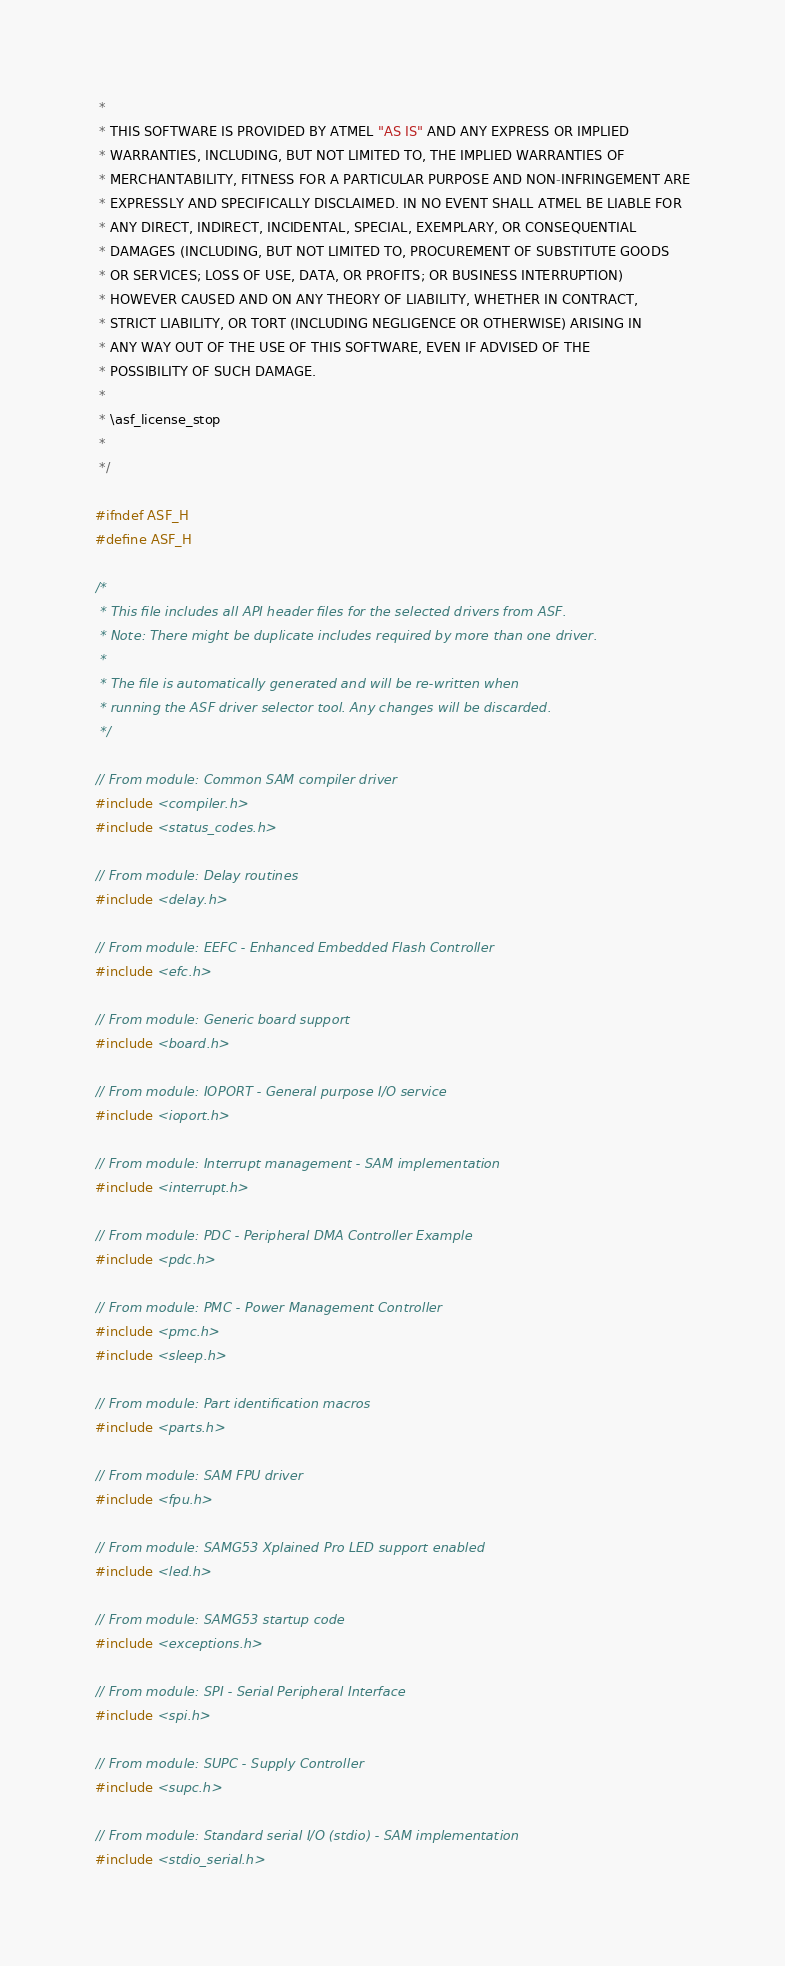Convert code to text. <code><loc_0><loc_0><loc_500><loc_500><_C_> *
 * THIS SOFTWARE IS PROVIDED BY ATMEL "AS IS" AND ANY EXPRESS OR IMPLIED
 * WARRANTIES, INCLUDING, BUT NOT LIMITED TO, THE IMPLIED WARRANTIES OF
 * MERCHANTABILITY, FITNESS FOR A PARTICULAR PURPOSE AND NON-INFRINGEMENT ARE
 * EXPRESSLY AND SPECIFICALLY DISCLAIMED. IN NO EVENT SHALL ATMEL BE LIABLE FOR
 * ANY DIRECT, INDIRECT, INCIDENTAL, SPECIAL, EXEMPLARY, OR CONSEQUENTIAL
 * DAMAGES (INCLUDING, BUT NOT LIMITED TO, PROCUREMENT OF SUBSTITUTE GOODS
 * OR SERVICES; LOSS OF USE, DATA, OR PROFITS; OR BUSINESS INTERRUPTION)
 * HOWEVER CAUSED AND ON ANY THEORY OF LIABILITY, WHETHER IN CONTRACT,
 * STRICT LIABILITY, OR TORT (INCLUDING NEGLIGENCE OR OTHERWISE) ARISING IN
 * ANY WAY OUT OF THE USE OF THIS SOFTWARE, EVEN IF ADVISED OF THE
 * POSSIBILITY OF SUCH DAMAGE.
 *
 * \asf_license_stop
 *
 */

#ifndef ASF_H
#define ASF_H

/*
 * This file includes all API header files for the selected drivers from ASF.
 * Note: There might be duplicate includes required by more than one driver.
 *
 * The file is automatically generated and will be re-written when
 * running the ASF driver selector tool. Any changes will be discarded.
 */

// From module: Common SAM compiler driver
#include <compiler.h>
#include <status_codes.h>

// From module: Delay routines
#include <delay.h>

// From module: EEFC - Enhanced Embedded Flash Controller
#include <efc.h>

// From module: Generic board support
#include <board.h>

// From module: IOPORT - General purpose I/O service
#include <ioport.h>

// From module: Interrupt management - SAM implementation
#include <interrupt.h>

// From module: PDC - Peripheral DMA Controller Example
#include <pdc.h>

// From module: PMC - Power Management Controller
#include <pmc.h>
#include <sleep.h>

// From module: Part identification macros
#include <parts.h>

// From module: SAM FPU driver
#include <fpu.h>

// From module: SAMG53 Xplained Pro LED support enabled
#include <led.h>

// From module: SAMG53 startup code
#include <exceptions.h>

// From module: SPI - Serial Peripheral Interface
#include <spi.h>

// From module: SUPC - Supply Controller
#include <supc.h>

// From module: Standard serial I/O (stdio) - SAM implementation
#include <stdio_serial.h>
</code> 